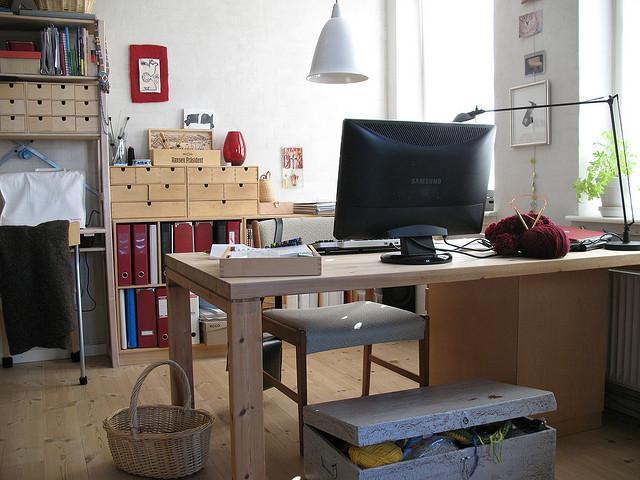How many books are in the picture?
Give a very brief answer. 1. How many bicycles are on the blue sign?
Give a very brief answer. 0. 